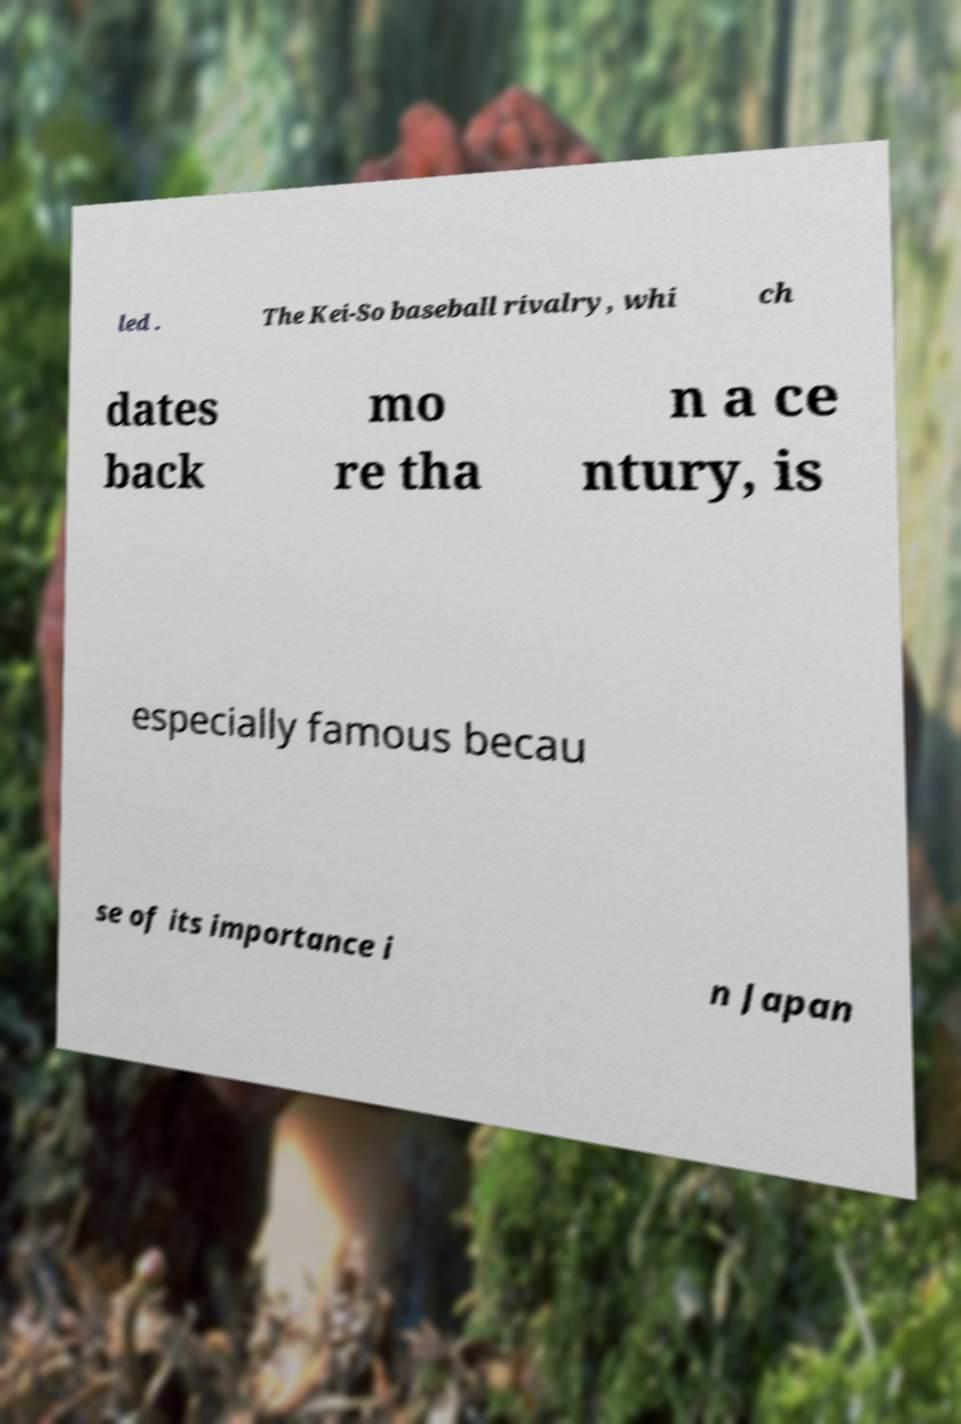Please read and relay the text visible in this image. What does it say? led . The Kei-So baseball rivalry, whi ch dates back mo re tha n a ce ntury, is especially famous becau se of its importance i n Japan 